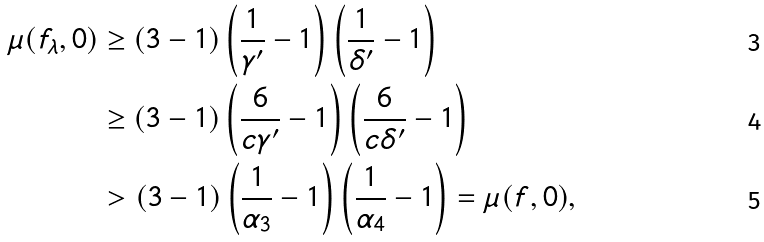Convert formula to latex. <formula><loc_0><loc_0><loc_500><loc_500>\mu ( f _ { \lambda } , 0 ) & \geq ( 3 - 1 ) \left ( \frac { 1 } { \gamma ^ { \prime } } - 1 \right ) \left ( \frac { 1 } { \delta ^ { \prime } } - 1 \right ) \\ & \geq ( 3 - 1 ) \left ( \frac { 6 } { c \gamma ^ { \prime } } - 1 \right ) \left ( \frac { 6 } { c \delta ^ { \prime } } - 1 \right ) \\ & > ( 3 - 1 ) \left ( \frac { 1 } { \alpha _ { 3 } } - 1 \right ) \left ( \frac { 1 } { \alpha _ { 4 } } - 1 \right ) = \mu ( f , 0 ) ,</formula> 